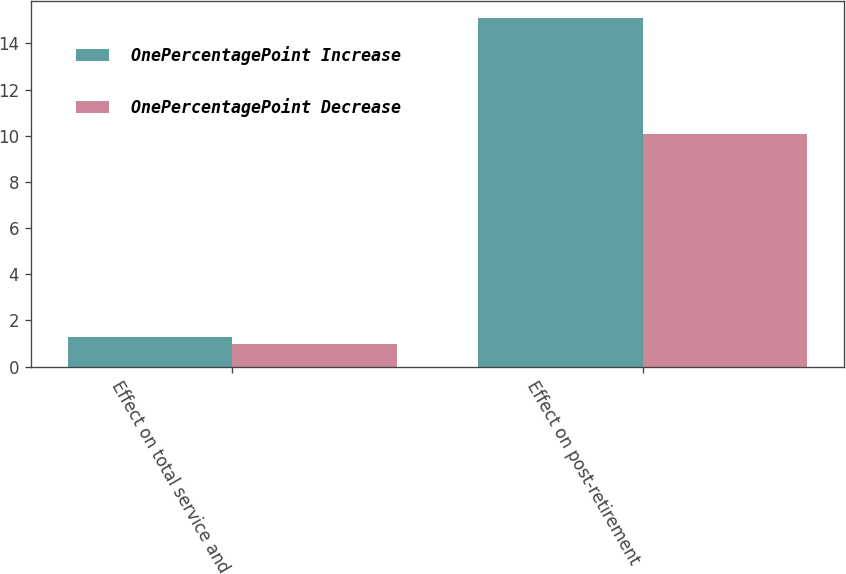Convert chart. <chart><loc_0><loc_0><loc_500><loc_500><stacked_bar_chart><ecel><fcel>Effect on total service and<fcel>Effect on post-retirement<nl><fcel>OnePercentagePoint Increase<fcel>1.3<fcel>15.1<nl><fcel>OnePercentagePoint Decrease<fcel>1<fcel>10.1<nl></chart> 